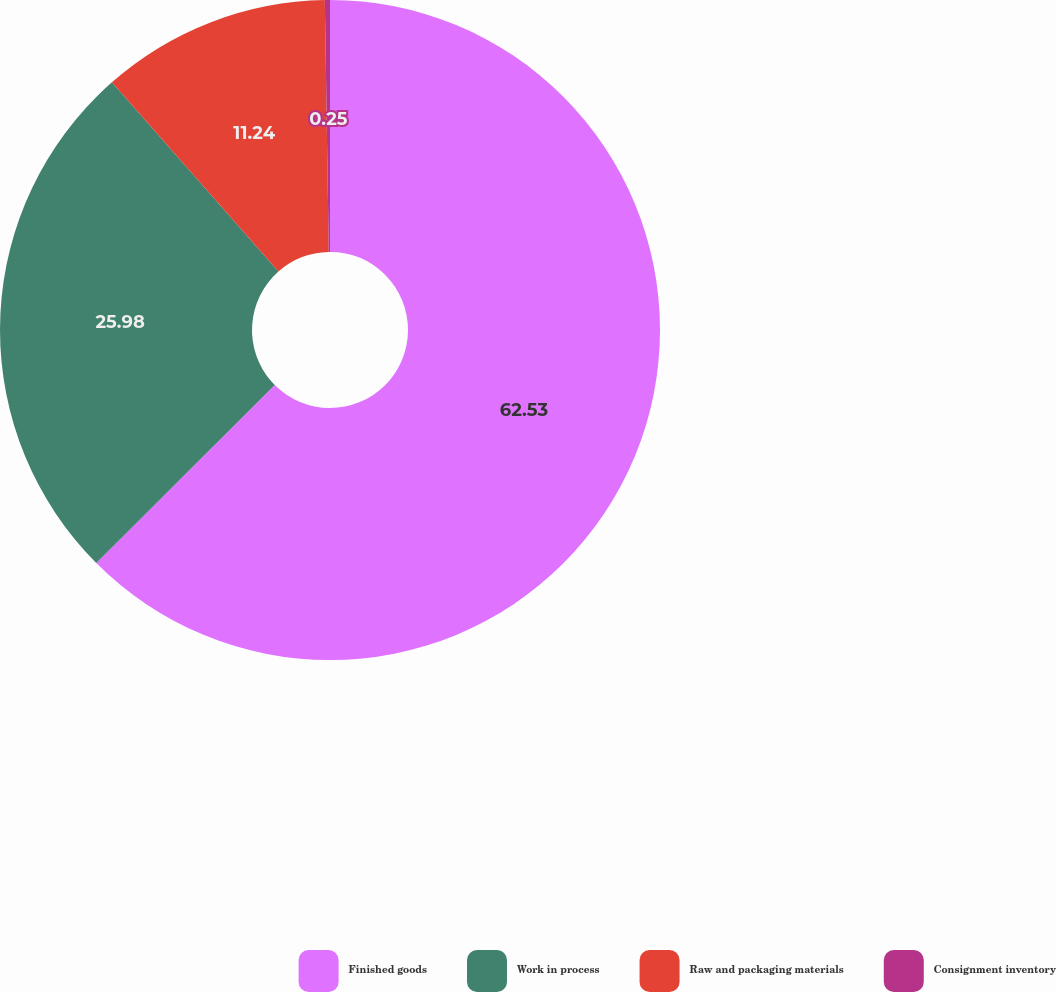<chart> <loc_0><loc_0><loc_500><loc_500><pie_chart><fcel>Finished goods<fcel>Work in process<fcel>Raw and packaging materials<fcel>Consignment inventory<nl><fcel>62.52%<fcel>25.98%<fcel>11.24%<fcel>0.25%<nl></chart> 